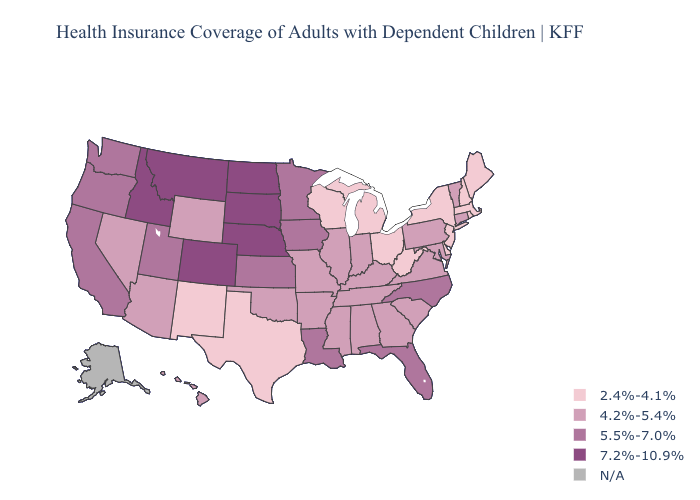Does Maryland have the lowest value in the USA?
Answer briefly. No. Is the legend a continuous bar?
Write a very short answer. No. Name the states that have a value in the range 5.5%-7.0%?
Write a very short answer. California, Florida, Iowa, Kansas, Louisiana, Minnesota, North Carolina, Oregon, Utah, Washington. What is the lowest value in the USA?
Answer briefly. 2.4%-4.1%. Name the states that have a value in the range 4.2%-5.4%?
Be succinct. Alabama, Arizona, Arkansas, Connecticut, Georgia, Hawaii, Illinois, Indiana, Kentucky, Maryland, Mississippi, Missouri, Nevada, Oklahoma, Pennsylvania, South Carolina, Tennessee, Vermont, Virginia, Wyoming. Name the states that have a value in the range N/A?
Answer briefly. Alaska. What is the lowest value in states that border Missouri?
Be succinct. 4.2%-5.4%. Name the states that have a value in the range 2.4%-4.1%?
Short answer required. Delaware, Maine, Massachusetts, Michigan, New Hampshire, New Jersey, New Mexico, New York, Ohio, Rhode Island, Texas, West Virginia, Wisconsin. Does South Dakota have the highest value in the USA?
Keep it brief. Yes. Among the states that border Mississippi , does Alabama have the lowest value?
Be succinct. Yes. Name the states that have a value in the range 5.5%-7.0%?
Answer briefly. California, Florida, Iowa, Kansas, Louisiana, Minnesota, North Carolina, Oregon, Utah, Washington. Name the states that have a value in the range N/A?
Concise answer only. Alaska. Does West Virginia have the lowest value in the South?
Write a very short answer. Yes. 